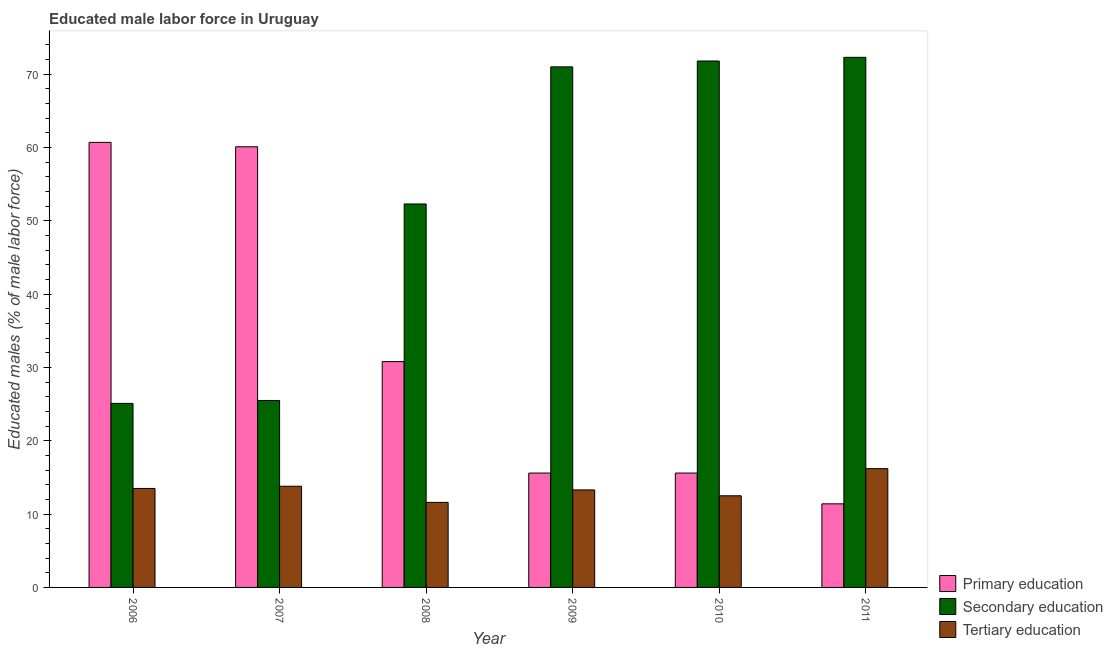How many different coloured bars are there?
Your response must be concise. 3. How many groups of bars are there?
Give a very brief answer. 6. Are the number of bars per tick equal to the number of legend labels?
Offer a very short reply. Yes. Are the number of bars on each tick of the X-axis equal?
Your answer should be compact. Yes. How many bars are there on the 6th tick from the left?
Ensure brevity in your answer.  3. What is the label of the 5th group of bars from the left?
Offer a terse response. 2010. What is the percentage of male labor force who received tertiary education in 2008?
Provide a short and direct response. 11.6. Across all years, what is the maximum percentage of male labor force who received secondary education?
Provide a succinct answer. 72.3. Across all years, what is the minimum percentage of male labor force who received primary education?
Keep it short and to the point. 11.4. In which year was the percentage of male labor force who received secondary education minimum?
Give a very brief answer. 2006. What is the total percentage of male labor force who received primary education in the graph?
Provide a short and direct response. 194.2. What is the difference between the percentage of male labor force who received tertiary education in 2008 and that in 2010?
Your answer should be very brief. -0.9. What is the difference between the percentage of male labor force who received primary education in 2007 and the percentage of male labor force who received secondary education in 2008?
Give a very brief answer. 29.3. What is the average percentage of male labor force who received primary education per year?
Your answer should be compact. 32.37. In the year 2010, what is the difference between the percentage of male labor force who received secondary education and percentage of male labor force who received primary education?
Your response must be concise. 0. In how many years, is the percentage of male labor force who received secondary education greater than 4 %?
Your response must be concise. 6. What is the ratio of the percentage of male labor force who received primary education in 2009 to that in 2011?
Your answer should be very brief. 1.37. Is the percentage of male labor force who received primary education in 2007 less than that in 2009?
Ensure brevity in your answer.  No. Is the difference between the percentage of male labor force who received secondary education in 2006 and 2007 greater than the difference between the percentage of male labor force who received tertiary education in 2006 and 2007?
Your answer should be very brief. No. What is the difference between the highest and the second highest percentage of male labor force who received tertiary education?
Offer a very short reply. 2.4. What is the difference between the highest and the lowest percentage of male labor force who received secondary education?
Offer a very short reply. 47.2. In how many years, is the percentage of male labor force who received secondary education greater than the average percentage of male labor force who received secondary education taken over all years?
Your answer should be compact. 3. Is the sum of the percentage of male labor force who received tertiary education in 2008 and 2009 greater than the maximum percentage of male labor force who received secondary education across all years?
Make the answer very short. Yes. What does the 1st bar from the left in 2008 represents?
Your answer should be compact. Primary education. What does the 1st bar from the right in 2010 represents?
Your response must be concise. Tertiary education. How many years are there in the graph?
Your answer should be very brief. 6. Are the values on the major ticks of Y-axis written in scientific E-notation?
Your answer should be compact. No. Does the graph contain any zero values?
Provide a short and direct response. No. Does the graph contain grids?
Make the answer very short. No. Where does the legend appear in the graph?
Give a very brief answer. Bottom right. How many legend labels are there?
Offer a very short reply. 3. What is the title of the graph?
Your response must be concise. Educated male labor force in Uruguay. What is the label or title of the X-axis?
Ensure brevity in your answer.  Year. What is the label or title of the Y-axis?
Offer a very short reply. Educated males (% of male labor force). What is the Educated males (% of male labor force) in Primary education in 2006?
Provide a short and direct response. 60.7. What is the Educated males (% of male labor force) in Secondary education in 2006?
Offer a very short reply. 25.1. What is the Educated males (% of male labor force) of Tertiary education in 2006?
Give a very brief answer. 13.5. What is the Educated males (% of male labor force) in Primary education in 2007?
Your answer should be compact. 60.1. What is the Educated males (% of male labor force) in Tertiary education in 2007?
Provide a succinct answer. 13.8. What is the Educated males (% of male labor force) in Primary education in 2008?
Offer a terse response. 30.8. What is the Educated males (% of male labor force) of Secondary education in 2008?
Make the answer very short. 52.3. What is the Educated males (% of male labor force) in Tertiary education in 2008?
Ensure brevity in your answer.  11.6. What is the Educated males (% of male labor force) in Primary education in 2009?
Provide a succinct answer. 15.6. What is the Educated males (% of male labor force) in Secondary education in 2009?
Provide a succinct answer. 71. What is the Educated males (% of male labor force) of Tertiary education in 2009?
Keep it short and to the point. 13.3. What is the Educated males (% of male labor force) in Primary education in 2010?
Your answer should be very brief. 15.6. What is the Educated males (% of male labor force) in Secondary education in 2010?
Offer a terse response. 71.8. What is the Educated males (% of male labor force) in Primary education in 2011?
Your response must be concise. 11.4. What is the Educated males (% of male labor force) of Secondary education in 2011?
Offer a very short reply. 72.3. What is the Educated males (% of male labor force) in Tertiary education in 2011?
Keep it short and to the point. 16.2. Across all years, what is the maximum Educated males (% of male labor force) of Primary education?
Make the answer very short. 60.7. Across all years, what is the maximum Educated males (% of male labor force) in Secondary education?
Offer a very short reply. 72.3. Across all years, what is the maximum Educated males (% of male labor force) of Tertiary education?
Provide a short and direct response. 16.2. Across all years, what is the minimum Educated males (% of male labor force) in Primary education?
Provide a succinct answer. 11.4. Across all years, what is the minimum Educated males (% of male labor force) of Secondary education?
Offer a terse response. 25.1. Across all years, what is the minimum Educated males (% of male labor force) in Tertiary education?
Ensure brevity in your answer.  11.6. What is the total Educated males (% of male labor force) of Primary education in the graph?
Give a very brief answer. 194.2. What is the total Educated males (% of male labor force) of Secondary education in the graph?
Provide a succinct answer. 318. What is the total Educated males (% of male labor force) in Tertiary education in the graph?
Offer a very short reply. 80.9. What is the difference between the Educated males (% of male labor force) of Primary education in 2006 and that in 2007?
Provide a succinct answer. 0.6. What is the difference between the Educated males (% of male labor force) of Secondary education in 2006 and that in 2007?
Give a very brief answer. -0.4. What is the difference between the Educated males (% of male labor force) in Tertiary education in 2006 and that in 2007?
Make the answer very short. -0.3. What is the difference between the Educated males (% of male labor force) of Primary education in 2006 and that in 2008?
Your response must be concise. 29.9. What is the difference between the Educated males (% of male labor force) in Secondary education in 2006 and that in 2008?
Offer a very short reply. -27.2. What is the difference between the Educated males (% of male labor force) in Tertiary education in 2006 and that in 2008?
Provide a short and direct response. 1.9. What is the difference between the Educated males (% of male labor force) of Primary education in 2006 and that in 2009?
Offer a very short reply. 45.1. What is the difference between the Educated males (% of male labor force) of Secondary education in 2006 and that in 2009?
Offer a terse response. -45.9. What is the difference between the Educated males (% of male labor force) in Primary education in 2006 and that in 2010?
Provide a short and direct response. 45.1. What is the difference between the Educated males (% of male labor force) in Secondary education in 2006 and that in 2010?
Your answer should be compact. -46.7. What is the difference between the Educated males (% of male labor force) of Tertiary education in 2006 and that in 2010?
Make the answer very short. 1. What is the difference between the Educated males (% of male labor force) of Primary education in 2006 and that in 2011?
Your answer should be compact. 49.3. What is the difference between the Educated males (% of male labor force) in Secondary education in 2006 and that in 2011?
Provide a succinct answer. -47.2. What is the difference between the Educated males (% of male labor force) in Tertiary education in 2006 and that in 2011?
Your answer should be very brief. -2.7. What is the difference between the Educated males (% of male labor force) of Primary education in 2007 and that in 2008?
Keep it short and to the point. 29.3. What is the difference between the Educated males (% of male labor force) of Secondary education in 2007 and that in 2008?
Give a very brief answer. -26.8. What is the difference between the Educated males (% of male labor force) of Tertiary education in 2007 and that in 2008?
Offer a very short reply. 2.2. What is the difference between the Educated males (% of male labor force) in Primary education in 2007 and that in 2009?
Offer a very short reply. 44.5. What is the difference between the Educated males (% of male labor force) of Secondary education in 2007 and that in 2009?
Provide a short and direct response. -45.5. What is the difference between the Educated males (% of male labor force) of Tertiary education in 2007 and that in 2009?
Your answer should be very brief. 0.5. What is the difference between the Educated males (% of male labor force) of Primary education in 2007 and that in 2010?
Your answer should be very brief. 44.5. What is the difference between the Educated males (% of male labor force) of Secondary education in 2007 and that in 2010?
Provide a short and direct response. -46.3. What is the difference between the Educated males (% of male labor force) of Primary education in 2007 and that in 2011?
Provide a succinct answer. 48.7. What is the difference between the Educated males (% of male labor force) in Secondary education in 2007 and that in 2011?
Give a very brief answer. -46.8. What is the difference between the Educated males (% of male labor force) of Tertiary education in 2007 and that in 2011?
Provide a succinct answer. -2.4. What is the difference between the Educated males (% of male labor force) of Primary education in 2008 and that in 2009?
Your answer should be compact. 15.2. What is the difference between the Educated males (% of male labor force) of Secondary education in 2008 and that in 2009?
Your answer should be compact. -18.7. What is the difference between the Educated males (% of male labor force) of Secondary education in 2008 and that in 2010?
Provide a succinct answer. -19.5. What is the difference between the Educated males (% of male labor force) of Tertiary education in 2008 and that in 2010?
Provide a succinct answer. -0.9. What is the difference between the Educated males (% of male labor force) in Secondary education in 2008 and that in 2011?
Your answer should be compact. -20. What is the difference between the Educated males (% of male labor force) in Tertiary education in 2008 and that in 2011?
Keep it short and to the point. -4.6. What is the difference between the Educated males (% of male labor force) of Tertiary education in 2009 and that in 2011?
Your answer should be very brief. -2.9. What is the difference between the Educated males (% of male labor force) of Primary education in 2010 and that in 2011?
Your response must be concise. 4.2. What is the difference between the Educated males (% of male labor force) of Tertiary education in 2010 and that in 2011?
Keep it short and to the point. -3.7. What is the difference between the Educated males (% of male labor force) in Primary education in 2006 and the Educated males (% of male labor force) in Secondary education in 2007?
Offer a very short reply. 35.2. What is the difference between the Educated males (% of male labor force) in Primary education in 2006 and the Educated males (% of male labor force) in Tertiary education in 2007?
Your answer should be compact. 46.9. What is the difference between the Educated males (% of male labor force) of Secondary education in 2006 and the Educated males (% of male labor force) of Tertiary education in 2007?
Provide a succinct answer. 11.3. What is the difference between the Educated males (% of male labor force) in Primary education in 2006 and the Educated males (% of male labor force) in Secondary education in 2008?
Provide a succinct answer. 8.4. What is the difference between the Educated males (% of male labor force) of Primary education in 2006 and the Educated males (% of male labor force) of Tertiary education in 2008?
Give a very brief answer. 49.1. What is the difference between the Educated males (% of male labor force) in Primary education in 2006 and the Educated males (% of male labor force) in Tertiary education in 2009?
Offer a very short reply. 47.4. What is the difference between the Educated males (% of male labor force) of Secondary education in 2006 and the Educated males (% of male labor force) of Tertiary education in 2009?
Provide a succinct answer. 11.8. What is the difference between the Educated males (% of male labor force) of Primary education in 2006 and the Educated males (% of male labor force) of Secondary education in 2010?
Provide a succinct answer. -11.1. What is the difference between the Educated males (% of male labor force) in Primary education in 2006 and the Educated males (% of male labor force) in Tertiary education in 2010?
Your response must be concise. 48.2. What is the difference between the Educated males (% of male labor force) in Primary education in 2006 and the Educated males (% of male labor force) in Tertiary education in 2011?
Make the answer very short. 44.5. What is the difference between the Educated males (% of male labor force) of Primary education in 2007 and the Educated males (% of male labor force) of Secondary education in 2008?
Your answer should be compact. 7.8. What is the difference between the Educated males (% of male labor force) in Primary education in 2007 and the Educated males (% of male labor force) in Tertiary education in 2008?
Ensure brevity in your answer.  48.5. What is the difference between the Educated males (% of male labor force) in Secondary education in 2007 and the Educated males (% of male labor force) in Tertiary education in 2008?
Offer a terse response. 13.9. What is the difference between the Educated males (% of male labor force) in Primary education in 2007 and the Educated males (% of male labor force) in Secondary education in 2009?
Make the answer very short. -10.9. What is the difference between the Educated males (% of male labor force) of Primary education in 2007 and the Educated males (% of male labor force) of Tertiary education in 2009?
Offer a very short reply. 46.8. What is the difference between the Educated males (% of male labor force) of Primary education in 2007 and the Educated males (% of male labor force) of Secondary education in 2010?
Ensure brevity in your answer.  -11.7. What is the difference between the Educated males (% of male labor force) of Primary education in 2007 and the Educated males (% of male labor force) of Tertiary education in 2010?
Keep it short and to the point. 47.6. What is the difference between the Educated males (% of male labor force) of Secondary education in 2007 and the Educated males (% of male labor force) of Tertiary education in 2010?
Make the answer very short. 13. What is the difference between the Educated males (% of male labor force) in Primary education in 2007 and the Educated males (% of male labor force) in Tertiary education in 2011?
Provide a succinct answer. 43.9. What is the difference between the Educated males (% of male labor force) of Secondary education in 2007 and the Educated males (% of male labor force) of Tertiary education in 2011?
Your answer should be compact. 9.3. What is the difference between the Educated males (% of male labor force) in Primary education in 2008 and the Educated males (% of male labor force) in Secondary education in 2009?
Give a very brief answer. -40.2. What is the difference between the Educated males (% of male labor force) in Primary education in 2008 and the Educated males (% of male labor force) in Secondary education in 2010?
Your answer should be very brief. -41. What is the difference between the Educated males (% of male labor force) in Primary education in 2008 and the Educated males (% of male labor force) in Tertiary education in 2010?
Give a very brief answer. 18.3. What is the difference between the Educated males (% of male labor force) of Secondary education in 2008 and the Educated males (% of male labor force) of Tertiary education in 2010?
Your answer should be compact. 39.8. What is the difference between the Educated males (% of male labor force) of Primary education in 2008 and the Educated males (% of male labor force) of Secondary education in 2011?
Offer a terse response. -41.5. What is the difference between the Educated males (% of male labor force) in Primary education in 2008 and the Educated males (% of male labor force) in Tertiary education in 2011?
Offer a terse response. 14.6. What is the difference between the Educated males (% of male labor force) of Secondary education in 2008 and the Educated males (% of male labor force) of Tertiary education in 2011?
Provide a short and direct response. 36.1. What is the difference between the Educated males (% of male labor force) in Primary education in 2009 and the Educated males (% of male labor force) in Secondary education in 2010?
Offer a very short reply. -56.2. What is the difference between the Educated males (% of male labor force) of Secondary education in 2009 and the Educated males (% of male labor force) of Tertiary education in 2010?
Offer a terse response. 58.5. What is the difference between the Educated males (% of male labor force) of Primary education in 2009 and the Educated males (% of male labor force) of Secondary education in 2011?
Provide a short and direct response. -56.7. What is the difference between the Educated males (% of male labor force) of Primary education in 2009 and the Educated males (% of male labor force) of Tertiary education in 2011?
Your answer should be compact. -0.6. What is the difference between the Educated males (% of male labor force) in Secondary education in 2009 and the Educated males (% of male labor force) in Tertiary education in 2011?
Offer a terse response. 54.8. What is the difference between the Educated males (% of male labor force) in Primary education in 2010 and the Educated males (% of male labor force) in Secondary education in 2011?
Ensure brevity in your answer.  -56.7. What is the difference between the Educated males (% of male labor force) in Secondary education in 2010 and the Educated males (% of male labor force) in Tertiary education in 2011?
Offer a terse response. 55.6. What is the average Educated males (% of male labor force) of Primary education per year?
Provide a short and direct response. 32.37. What is the average Educated males (% of male labor force) of Tertiary education per year?
Ensure brevity in your answer.  13.48. In the year 2006, what is the difference between the Educated males (% of male labor force) of Primary education and Educated males (% of male labor force) of Secondary education?
Your answer should be compact. 35.6. In the year 2006, what is the difference between the Educated males (% of male labor force) of Primary education and Educated males (% of male labor force) of Tertiary education?
Give a very brief answer. 47.2. In the year 2007, what is the difference between the Educated males (% of male labor force) in Primary education and Educated males (% of male labor force) in Secondary education?
Ensure brevity in your answer.  34.6. In the year 2007, what is the difference between the Educated males (% of male labor force) in Primary education and Educated males (% of male labor force) in Tertiary education?
Provide a short and direct response. 46.3. In the year 2008, what is the difference between the Educated males (% of male labor force) in Primary education and Educated males (% of male labor force) in Secondary education?
Ensure brevity in your answer.  -21.5. In the year 2008, what is the difference between the Educated males (% of male labor force) in Primary education and Educated males (% of male labor force) in Tertiary education?
Offer a very short reply. 19.2. In the year 2008, what is the difference between the Educated males (% of male labor force) in Secondary education and Educated males (% of male labor force) in Tertiary education?
Ensure brevity in your answer.  40.7. In the year 2009, what is the difference between the Educated males (% of male labor force) of Primary education and Educated males (% of male labor force) of Secondary education?
Ensure brevity in your answer.  -55.4. In the year 2009, what is the difference between the Educated males (% of male labor force) in Secondary education and Educated males (% of male labor force) in Tertiary education?
Keep it short and to the point. 57.7. In the year 2010, what is the difference between the Educated males (% of male labor force) in Primary education and Educated males (% of male labor force) in Secondary education?
Give a very brief answer. -56.2. In the year 2010, what is the difference between the Educated males (% of male labor force) of Primary education and Educated males (% of male labor force) of Tertiary education?
Make the answer very short. 3.1. In the year 2010, what is the difference between the Educated males (% of male labor force) in Secondary education and Educated males (% of male labor force) in Tertiary education?
Keep it short and to the point. 59.3. In the year 2011, what is the difference between the Educated males (% of male labor force) of Primary education and Educated males (% of male labor force) of Secondary education?
Provide a succinct answer. -60.9. In the year 2011, what is the difference between the Educated males (% of male labor force) in Primary education and Educated males (% of male labor force) in Tertiary education?
Your response must be concise. -4.8. In the year 2011, what is the difference between the Educated males (% of male labor force) in Secondary education and Educated males (% of male labor force) in Tertiary education?
Offer a very short reply. 56.1. What is the ratio of the Educated males (% of male labor force) of Primary education in 2006 to that in 2007?
Make the answer very short. 1.01. What is the ratio of the Educated males (% of male labor force) of Secondary education in 2006 to that in 2007?
Ensure brevity in your answer.  0.98. What is the ratio of the Educated males (% of male labor force) of Tertiary education in 2006 to that in 2007?
Your answer should be compact. 0.98. What is the ratio of the Educated males (% of male labor force) in Primary education in 2006 to that in 2008?
Offer a terse response. 1.97. What is the ratio of the Educated males (% of male labor force) of Secondary education in 2006 to that in 2008?
Offer a terse response. 0.48. What is the ratio of the Educated males (% of male labor force) in Tertiary education in 2006 to that in 2008?
Your answer should be compact. 1.16. What is the ratio of the Educated males (% of male labor force) of Primary education in 2006 to that in 2009?
Provide a succinct answer. 3.89. What is the ratio of the Educated males (% of male labor force) of Secondary education in 2006 to that in 2009?
Provide a short and direct response. 0.35. What is the ratio of the Educated males (% of male labor force) in Primary education in 2006 to that in 2010?
Your answer should be very brief. 3.89. What is the ratio of the Educated males (% of male labor force) in Secondary education in 2006 to that in 2010?
Your answer should be compact. 0.35. What is the ratio of the Educated males (% of male labor force) of Primary education in 2006 to that in 2011?
Give a very brief answer. 5.32. What is the ratio of the Educated males (% of male labor force) of Secondary education in 2006 to that in 2011?
Offer a terse response. 0.35. What is the ratio of the Educated males (% of male labor force) of Tertiary education in 2006 to that in 2011?
Keep it short and to the point. 0.83. What is the ratio of the Educated males (% of male labor force) in Primary education in 2007 to that in 2008?
Offer a very short reply. 1.95. What is the ratio of the Educated males (% of male labor force) in Secondary education in 2007 to that in 2008?
Offer a terse response. 0.49. What is the ratio of the Educated males (% of male labor force) in Tertiary education in 2007 to that in 2008?
Keep it short and to the point. 1.19. What is the ratio of the Educated males (% of male labor force) in Primary education in 2007 to that in 2009?
Provide a succinct answer. 3.85. What is the ratio of the Educated males (% of male labor force) in Secondary education in 2007 to that in 2009?
Give a very brief answer. 0.36. What is the ratio of the Educated males (% of male labor force) in Tertiary education in 2007 to that in 2009?
Make the answer very short. 1.04. What is the ratio of the Educated males (% of male labor force) of Primary education in 2007 to that in 2010?
Your response must be concise. 3.85. What is the ratio of the Educated males (% of male labor force) in Secondary education in 2007 to that in 2010?
Your answer should be compact. 0.36. What is the ratio of the Educated males (% of male labor force) in Tertiary education in 2007 to that in 2010?
Make the answer very short. 1.1. What is the ratio of the Educated males (% of male labor force) of Primary education in 2007 to that in 2011?
Provide a succinct answer. 5.27. What is the ratio of the Educated males (% of male labor force) of Secondary education in 2007 to that in 2011?
Provide a short and direct response. 0.35. What is the ratio of the Educated males (% of male labor force) in Tertiary education in 2007 to that in 2011?
Provide a short and direct response. 0.85. What is the ratio of the Educated males (% of male labor force) in Primary education in 2008 to that in 2009?
Provide a short and direct response. 1.97. What is the ratio of the Educated males (% of male labor force) in Secondary education in 2008 to that in 2009?
Your answer should be very brief. 0.74. What is the ratio of the Educated males (% of male labor force) in Tertiary education in 2008 to that in 2009?
Your response must be concise. 0.87. What is the ratio of the Educated males (% of male labor force) of Primary education in 2008 to that in 2010?
Ensure brevity in your answer.  1.97. What is the ratio of the Educated males (% of male labor force) in Secondary education in 2008 to that in 2010?
Give a very brief answer. 0.73. What is the ratio of the Educated males (% of male labor force) in Tertiary education in 2008 to that in 2010?
Ensure brevity in your answer.  0.93. What is the ratio of the Educated males (% of male labor force) of Primary education in 2008 to that in 2011?
Give a very brief answer. 2.7. What is the ratio of the Educated males (% of male labor force) of Secondary education in 2008 to that in 2011?
Keep it short and to the point. 0.72. What is the ratio of the Educated males (% of male labor force) in Tertiary education in 2008 to that in 2011?
Your answer should be compact. 0.72. What is the ratio of the Educated males (% of male labor force) in Primary education in 2009 to that in 2010?
Offer a very short reply. 1. What is the ratio of the Educated males (% of male labor force) in Secondary education in 2009 to that in 2010?
Keep it short and to the point. 0.99. What is the ratio of the Educated males (% of male labor force) of Tertiary education in 2009 to that in 2010?
Your answer should be compact. 1.06. What is the ratio of the Educated males (% of male labor force) in Primary education in 2009 to that in 2011?
Provide a succinct answer. 1.37. What is the ratio of the Educated males (% of male labor force) in Secondary education in 2009 to that in 2011?
Your response must be concise. 0.98. What is the ratio of the Educated males (% of male labor force) of Tertiary education in 2009 to that in 2011?
Keep it short and to the point. 0.82. What is the ratio of the Educated males (% of male labor force) in Primary education in 2010 to that in 2011?
Provide a short and direct response. 1.37. What is the ratio of the Educated males (% of male labor force) in Secondary education in 2010 to that in 2011?
Offer a terse response. 0.99. What is the ratio of the Educated males (% of male labor force) of Tertiary education in 2010 to that in 2011?
Ensure brevity in your answer.  0.77. What is the difference between the highest and the second highest Educated males (% of male labor force) of Tertiary education?
Your answer should be very brief. 2.4. What is the difference between the highest and the lowest Educated males (% of male labor force) in Primary education?
Offer a very short reply. 49.3. What is the difference between the highest and the lowest Educated males (% of male labor force) of Secondary education?
Keep it short and to the point. 47.2. 